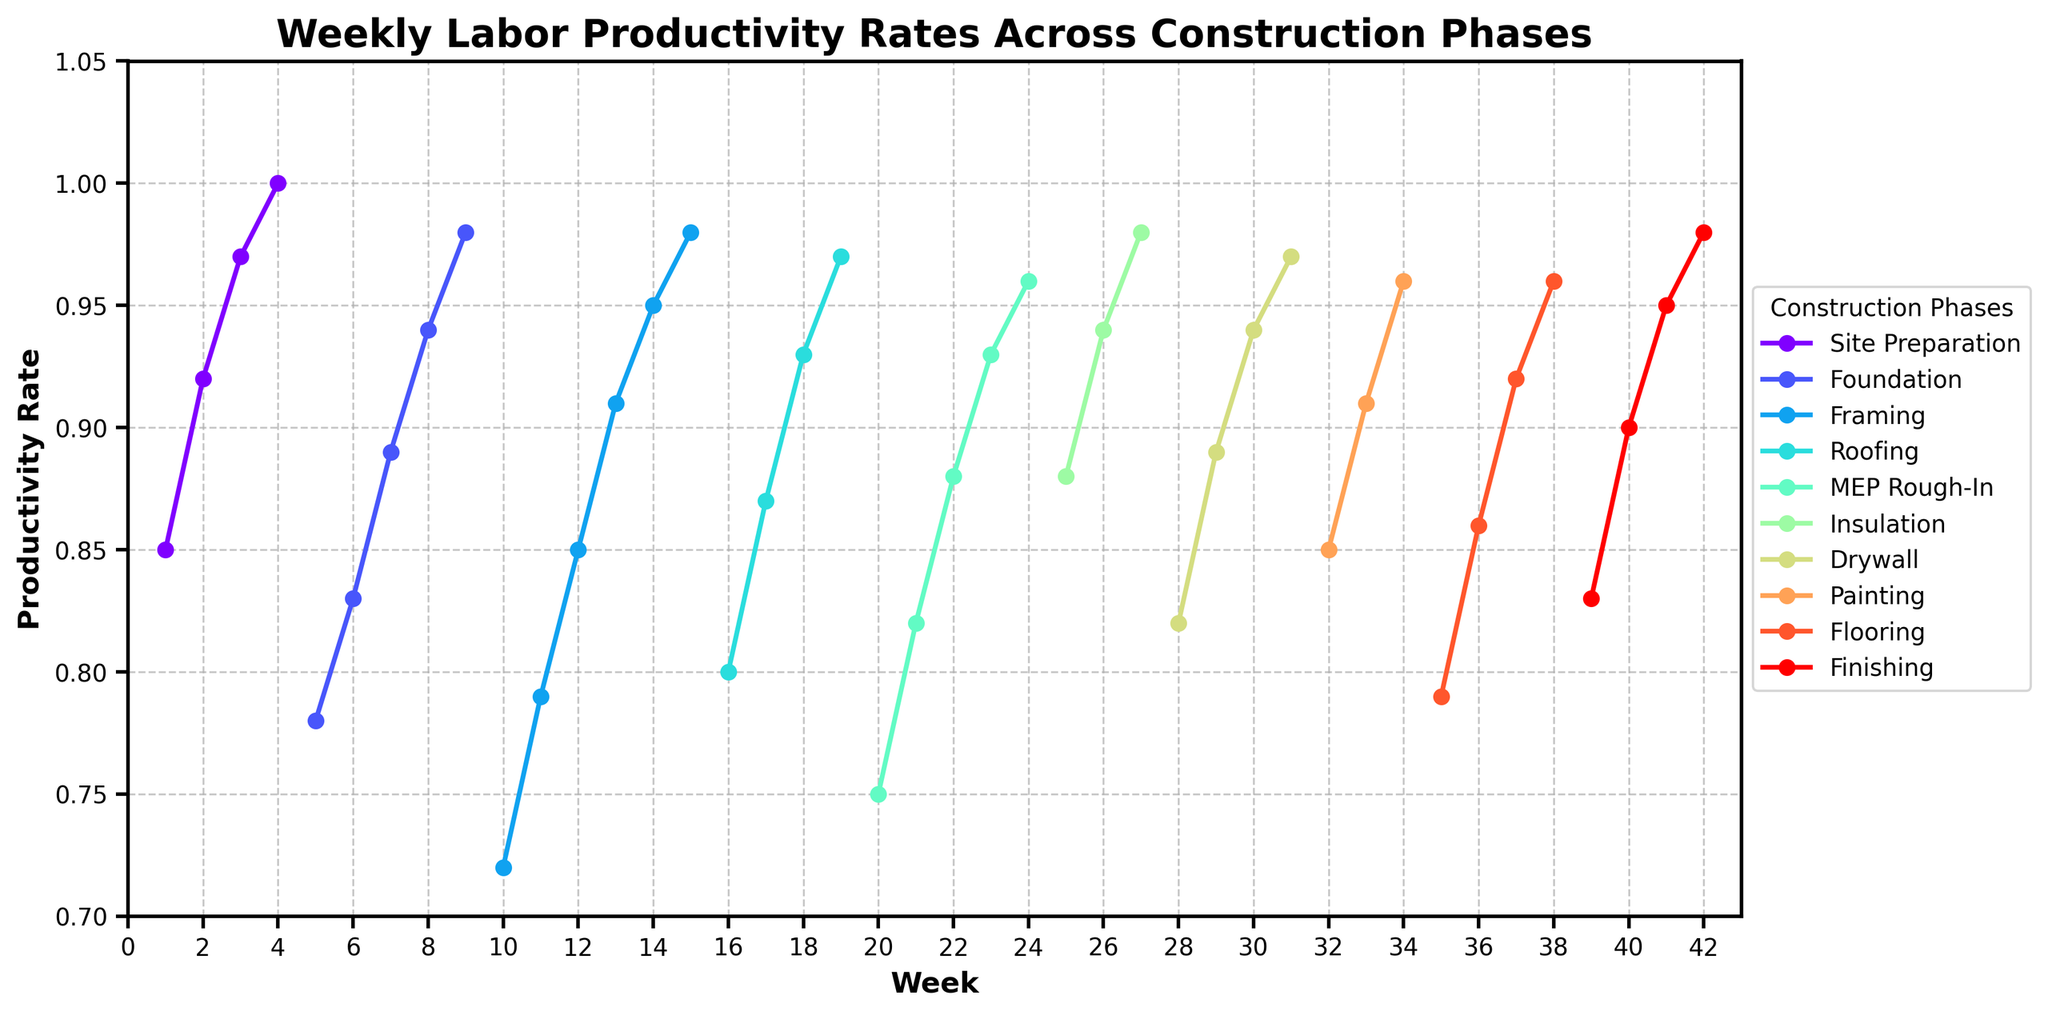Which construction phase shows the highest final productivity rate at the end of its timeline? To determine this, observe the productivity rates at the last week of each phase. Compare the productivity rates of the final week for each phase.
Answer: Finishing During which weeks was the productivity rate exactly 1.00? Look for points on the graph where the productivity rate reaches 1.00 and identify the corresponding weeks.
Answer: Week 4 What is the average productivity rate for the Foundation phase? Identify the productivity rates for weeks 5 to 9 which all fall under the Foundation phase. Sum these rates and then divide by the number of weeks. The sum of the productivity rates is (0.78 + 0.83 + 0.89 + 0.94 + 0.98) = 4.42. Dividing this by 5 weeks gives 4.42 / 5 = 0.884.
Answer: 0.884 How does the productivity rate for the first week of Framing compare to the first week of Roofing? Identify the productivity rate at week 10 (first week of Framing) and week 16 (first week of Roofing). Compare their values.
Answer: Framing is lower Which phase experienced the steepest increase in productivity rate over a single week? Observe the difference in productivity rates between consecutive weeks for each phase. The steepest increase is present where the difference between two points is the largest. For instance, inspecting all changes, from Week 1 to Week 2 and so forth, for all phases.
Answer: Site Preparation (Week 1 to Week 2) What's the total sum of the productivity rates for the weeks that fall under the Painting phase? Identify and sum the productivity rates corresponding to the Painting phase which are weeks 32 to 34. These rates are 0.85, 0.91, and 0.96. The total is 0.85 + 0.91 + 0.96 = 2.72.
Answer: 2.72 Which phase had the most consistent productivity improvement over time? Check for phases where the productivity rate incrementally increased each week without any decrease. Each phase's weekly productivity should be examined for consistent incremental increases.
Answer: Framing How does the final productivity rate of Insulation compare to that of Drywall? Identify the productivity rates of the final week for Insulation (week 27) and Drywall (week 31). Compare 0.98 for Insulation with 0.97 for Drywall.
Answer: Insulation is higher In which phase was the productivity rate lowest at any given point in time? Identify the phase with the lowest recorded productivity rate during any week. This involves scanning through the minimum productivity values for each phase. The lowest value in the dataset is 0.72 during Framing in week 10.
Answer: Framing What was the productivity rate trend for MEP Rough-In from start to end? Examine and describe the overall behavior of the productivity rate for the MEP Rough-In phase from week 20 to 24.
Answer: It steadily increased 